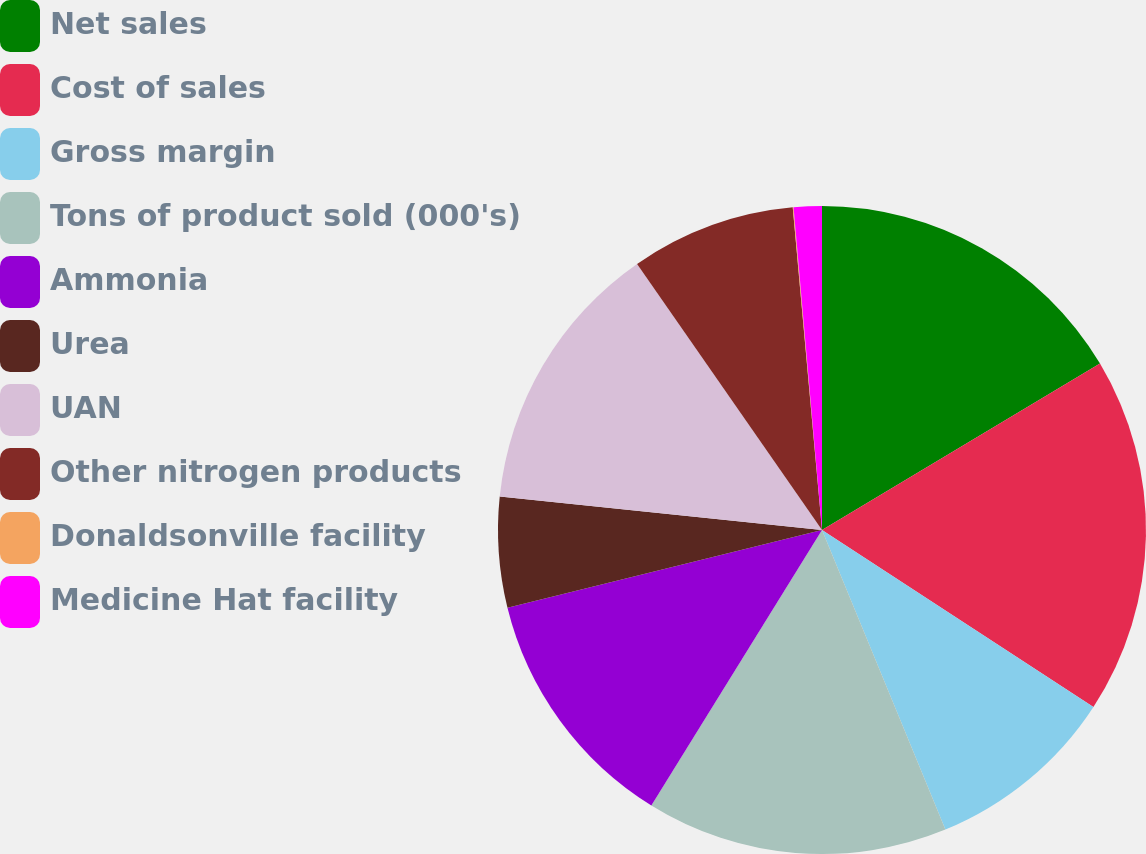Convert chart to OTSL. <chart><loc_0><loc_0><loc_500><loc_500><pie_chart><fcel>Net sales<fcel>Cost of sales<fcel>Gross margin<fcel>Tons of product sold (000's)<fcel>Ammonia<fcel>Urea<fcel>UAN<fcel>Other nitrogen products<fcel>Donaldsonville facility<fcel>Medicine Hat facility<nl><fcel>16.42%<fcel>17.78%<fcel>9.59%<fcel>15.05%<fcel>12.32%<fcel>5.5%<fcel>13.69%<fcel>8.23%<fcel>0.04%<fcel>1.4%<nl></chart> 